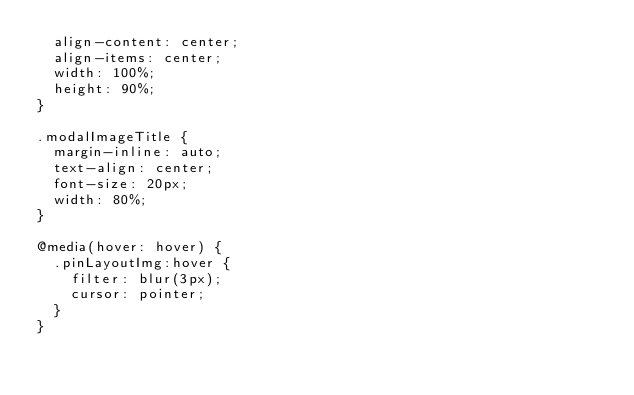<code> <loc_0><loc_0><loc_500><loc_500><_CSS_>  align-content: center;
  align-items: center;
  width: 100%;
  height: 90%;
}

.modalImageTitle {
  margin-inline: auto;
  text-align: center;
  font-size: 20px;
  width: 80%;
}

@media(hover: hover) {
  .pinLayoutImg:hover {
    filter: blur(3px);
    cursor: pointer;
  }
}</code> 